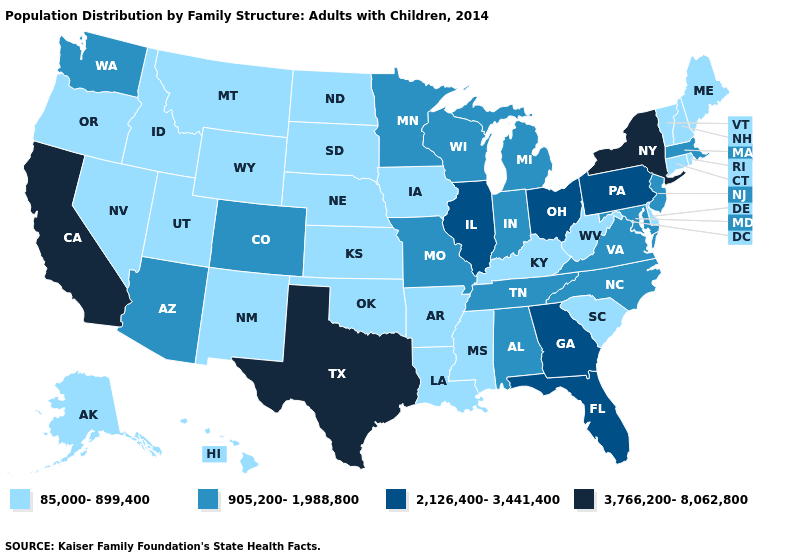What is the value of Wyoming?
Give a very brief answer. 85,000-899,400. Name the states that have a value in the range 905,200-1,988,800?
Quick response, please. Alabama, Arizona, Colorado, Indiana, Maryland, Massachusetts, Michigan, Minnesota, Missouri, New Jersey, North Carolina, Tennessee, Virginia, Washington, Wisconsin. Does the first symbol in the legend represent the smallest category?
Be succinct. Yes. Which states have the highest value in the USA?
Be succinct. California, New York, Texas. What is the highest value in the USA?
Quick response, please. 3,766,200-8,062,800. What is the value of Utah?
Quick response, please. 85,000-899,400. Does Ohio have the lowest value in the USA?
Keep it brief. No. Does the first symbol in the legend represent the smallest category?
Concise answer only. Yes. Does the first symbol in the legend represent the smallest category?
Keep it brief. Yes. Name the states that have a value in the range 85,000-899,400?
Give a very brief answer. Alaska, Arkansas, Connecticut, Delaware, Hawaii, Idaho, Iowa, Kansas, Kentucky, Louisiana, Maine, Mississippi, Montana, Nebraska, Nevada, New Hampshire, New Mexico, North Dakota, Oklahoma, Oregon, Rhode Island, South Carolina, South Dakota, Utah, Vermont, West Virginia, Wyoming. Among the states that border Wyoming , which have the highest value?
Answer briefly. Colorado. What is the value of Michigan?
Be succinct. 905,200-1,988,800. Name the states that have a value in the range 905,200-1,988,800?
Answer briefly. Alabama, Arizona, Colorado, Indiana, Maryland, Massachusetts, Michigan, Minnesota, Missouri, New Jersey, North Carolina, Tennessee, Virginia, Washington, Wisconsin. Which states hav the highest value in the Northeast?
Give a very brief answer. New York. Which states have the lowest value in the USA?
Write a very short answer. Alaska, Arkansas, Connecticut, Delaware, Hawaii, Idaho, Iowa, Kansas, Kentucky, Louisiana, Maine, Mississippi, Montana, Nebraska, Nevada, New Hampshire, New Mexico, North Dakota, Oklahoma, Oregon, Rhode Island, South Carolina, South Dakota, Utah, Vermont, West Virginia, Wyoming. 